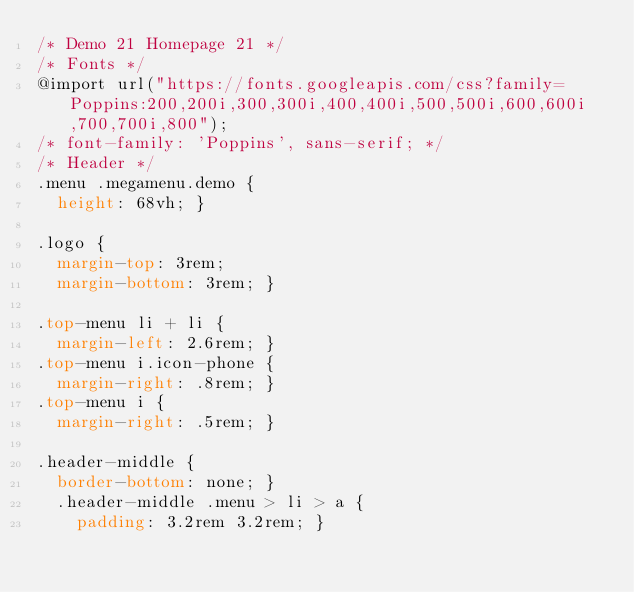<code> <loc_0><loc_0><loc_500><loc_500><_CSS_>/* Demo 21 Homepage 21 */
/* Fonts */
@import url("https://fonts.googleapis.com/css?family=Poppins:200,200i,300,300i,400,400i,500,500i,600,600i,700,700i,800");
/* font-family: 'Poppins', sans-serif; */
/* Header */
.menu .megamenu.demo {
  height: 68vh; }

.logo {
  margin-top: 3rem;
  margin-bottom: 3rem; }

.top-menu li + li {
  margin-left: 2.6rem; }
.top-menu i.icon-phone {
  margin-right: .8rem; }
.top-menu i {
  margin-right: .5rem; }

.header-middle {
  border-bottom: none; }
  .header-middle .menu > li > a {
    padding: 3.2rem 3.2rem; }</code> 